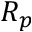<formula> <loc_0><loc_0><loc_500><loc_500>R _ { p }</formula> 